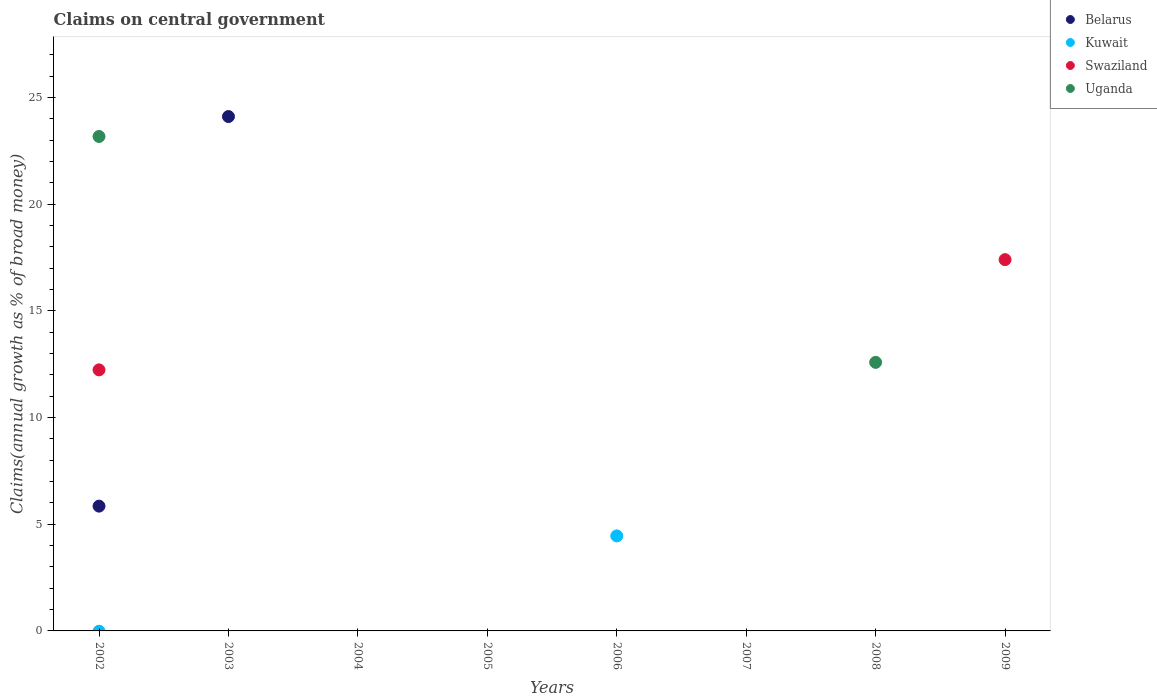How many different coloured dotlines are there?
Offer a terse response. 4. Is the number of dotlines equal to the number of legend labels?
Provide a succinct answer. No. What is the percentage of broad money claimed on centeral government in Uganda in 2007?
Provide a succinct answer. 0. Across all years, what is the maximum percentage of broad money claimed on centeral government in Kuwait?
Offer a terse response. 4.45. What is the total percentage of broad money claimed on centeral government in Swaziland in the graph?
Offer a very short reply. 29.63. What is the average percentage of broad money claimed on centeral government in Uganda per year?
Provide a succinct answer. 4.47. In the year 2002, what is the difference between the percentage of broad money claimed on centeral government in Belarus and percentage of broad money claimed on centeral government in Swaziland?
Make the answer very short. -6.39. In how many years, is the percentage of broad money claimed on centeral government in Kuwait greater than 9 %?
Make the answer very short. 0. What is the difference between the highest and the lowest percentage of broad money claimed on centeral government in Kuwait?
Provide a succinct answer. 4.45. Is it the case that in every year, the sum of the percentage of broad money claimed on centeral government in Kuwait and percentage of broad money claimed on centeral government in Uganda  is greater than the sum of percentage of broad money claimed on centeral government in Swaziland and percentage of broad money claimed on centeral government in Belarus?
Your response must be concise. No. Does the percentage of broad money claimed on centeral government in Uganda monotonically increase over the years?
Provide a succinct answer. No. How many years are there in the graph?
Your answer should be compact. 8. What is the difference between two consecutive major ticks on the Y-axis?
Make the answer very short. 5. Does the graph contain any zero values?
Give a very brief answer. Yes. Does the graph contain grids?
Ensure brevity in your answer.  No. Where does the legend appear in the graph?
Offer a very short reply. Top right. What is the title of the graph?
Give a very brief answer. Claims on central government. What is the label or title of the X-axis?
Keep it short and to the point. Years. What is the label or title of the Y-axis?
Your answer should be very brief. Claims(annual growth as % of broad money). What is the Claims(annual growth as % of broad money) of Belarus in 2002?
Provide a succinct answer. 5.85. What is the Claims(annual growth as % of broad money) of Kuwait in 2002?
Offer a terse response. 0. What is the Claims(annual growth as % of broad money) in Swaziland in 2002?
Offer a very short reply. 12.23. What is the Claims(annual growth as % of broad money) in Uganda in 2002?
Make the answer very short. 23.17. What is the Claims(annual growth as % of broad money) in Belarus in 2003?
Ensure brevity in your answer.  24.1. What is the Claims(annual growth as % of broad money) in Kuwait in 2003?
Your answer should be very brief. 0. What is the Claims(annual growth as % of broad money) in Uganda in 2003?
Offer a terse response. 0. What is the Claims(annual growth as % of broad money) in Belarus in 2004?
Your answer should be compact. 0. What is the Claims(annual growth as % of broad money) in Swaziland in 2004?
Ensure brevity in your answer.  0. What is the Claims(annual growth as % of broad money) in Belarus in 2005?
Provide a succinct answer. 0. What is the Claims(annual growth as % of broad money) in Kuwait in 2005?
Offer a terse response. 0. What is the Claims(annual growth as % of broad money) of Swaziland in 2005?
Provide a short and direct response. 0. What is the Claims(annual growth as % of broad money) of Uganda in 2005?
Your response must be concise. 0. What is the Claims(annual growth as % of broad money) of Kuwait in 2006?
Ensure brevity in your answer.  4.45. What is the Claims(annual growth as % of broad money) in Swaziland in 2006?
Your response must be concise. 0. What is the Claims(annual growth as % of broad money) of Kuwait in 2007?
Your answer should be compact. 0. What is the Claims(annual growth as % of broad money) in Belarus in 2008?
Your answer should be compact. 0. What is the Claims(annual growth as % of broad money) in Kuwait in 2008?
Make the answer very short. 0. What is the Claims(annual growth as % of broad money) of Uganda in 2008?
Make the answer very short. 12.59. What is the Claims(annual growth as % of broad money) in Belarus in 2009?
Your answer should be compact. 0. What is the Claims(annual growth as % of broad money) in Swaziland in 2009?
Make the answer very short. 17.4. Across all years, what is the maximum Claims(annual growth as % of broad money) in Belarus?
Provide a succinct answer. 24.1. Across all years, what is the maximum Claims(annual growth as % of broad money) of Kuwait?
Offer a terse response. 4.45. Across all years, what is the maximum Claims(annual growth as % of broad money) in Swaziland?
Give a very brief answer. 17.4. Across all years, what is the maximum Claims(annual growth as % of broad money) in Uganda?
Make the answer very short. 23.17. Across all years, what is the minimum Claims(annual growth as % of broad money) of Belarus?
Offer a terse response. 0. Across all years, what is the minimum Claims(annual growth as % of broad money) of Swaziland?
Your answer should be compact. 0. What is the total Claims(annual growth as % of broad money) of Belarus in the graph?
Make the answer very short. 29.95. What is the total Claims(annual growth as % of broad money) in Kuwait in the graph?
Give a very brief answer. 4.45. What is the total Claims(annual growth as % of broad money) of Swaziland in the graph?
Provide a succinct answer. 29.63. What is the total Claims(annual growth as % of broad money) in Uganda in the graph?
Your answer should be very brief. 35.76. What is the difference between the Claims(annual growth as % of broad money) in Belarus in 2002 and that in 2003?
Offer a very short reply. -18.26. What is the difference between the Claims(annual growth as % of broad money) in Uganda in 2002 and that in 2008?
Your answer should be compact. 10.59. What is the difference between the Claims(annual growth as % of broad money) in Swaziland in 2002 and that in 2009?
Your answer should be very brief. -5.17. What is the difference between the Claims(annual growth as % of broad money) of Belarus in 2002 and the Claims(annual growth as % of broad money) of Kuwait in 2006?
Ensure brevity in your answer.  1.4. What is the difference between the Claims(annual growth as % of broad money) of Belarus in 2002 and the Claims(annual growth as % of broad money) of Uganda in 2008?
Keep it short and to the point. -6.74. What is the difference between the Claims(annual growth as % of broad money) in Swaziland in 2002 and the Claims(annual growth as % of broad money) in Uganda in 2008?
Provide a succinct answer. -0.35. What is the difference between the Claims(annual growth as % of broad money) of Belarus in 2002 and the Claims(annual growth as % of broad money) of Swaziland in 2009?
Make the answer very short. -11.55. What is the difference between the Claims(annual growth as % of broad money) of Belarus in 2003 and the Claims(annual growth as % of broad money) of Kuwait in 2006?
Your answer should be very brief. 19.65. What is the difference between the Claims(annual growth as % of broad money) of Belarus in 2003 and the Claims(annual growth as % of broad money) of Uganda in 2008?
Your answer should be compact. 11.52. What is the difference between the Claims(annual growth as % of broad money) in Belarus in 2003 and the Claims(annual growth as % of broad money) in Swaziland in 2009?
Your answer should be compact. 6.71. What is the difference between the Claims(annual growth as % of broad money) of Kuwait in 2006 and the Claims(annual growth as % of broad money) of Uganda in 2008?
Ensure brevity in your answer.  -8.13. What is the difference between the Claims(annual growth as % of broad money) in Kuwait in 2006 and the Claims(annual growth as % of broad money) in Swaziland in 2009?
Ensure brevity in your answer.  -12.95. What is the average Claims(annual growth as % of broad money) in Belarus per year?
Your answer should be compact. 3.74. What is the average Claims(annual growth as % of broad money) of Kuwait per year?
Provide a short and direct response. 0.56. What is the average Claims(annual growth as % of broad money) of Swaziland per year?
Provide a short and direct response. 3.7. What is the average Claims(annual growth as % of broad money) in Uganda per year?
Provide a succinct answer. 4.47. In the year 2002, what is the difference between the Claims(annual growth as % of broad money) in Belarus and Claims(annual growth as % of broad money) in Swaziland?
Your answer should be compact. -6.39. In the year 2002, what is the difference between the Claims(annual growth as % of broad money) of Belarus and Claims(annual growth as % of broad money) of Uganda?
Provide a short and direct response. -17.32. In the year 2002, what is the difference between the Claims(annual growth as % of broad money) of Swaziland and Claims(annual growth as % of broad money) of Uganda?
Ensure brevity in your answer.  -10.94. What is the ratio of the Claims(annual growth as % of broad money) of Belarus in 2002 to that in 2003?
Provide a succinct answer. 0.24. What is the ratio of the Claims(annual growth as % of broad money) in Uganda in 2002 to that in 2008?
Your answer should be compact. 1.84. What is the ratio of the Claims(annual growth as % of broad money) of Swaziland in 2002 to that in 2009?
Keep it short and to the point. 0.7. What is the difference between the highest and the lowest Claims(annual growth as % of broad money) of Belarus?
Your answer should be compact. 24.1. What is the difference between the highest and the lowest Claims(annual growth as % of broad money) in Kuwait?
Give a very brief answer. 4.45. What is the difference between the highest and the lowest Claims(annual growth as % of broad money) in Swaziland?
Ensure brevity in your answer.  17.4. What is the difference between the highest and the lowest Claims(annual growth as % of broad money) of Uganda?
Provide a short and direct response. 23.17. 